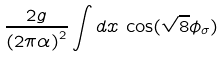<formula> <loc_0><loc_0><loc_500><loc_500>\frac { 2 g } { { ( 2 \pi \alpha ) } ^ { 2 } } \int d x \, \cos ( { \sqrt { 8 } \phi _ { \sigma } } )</formula> 